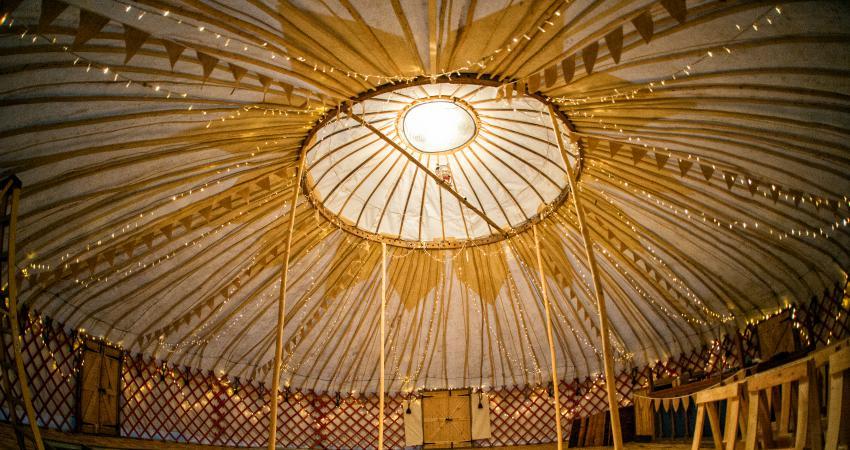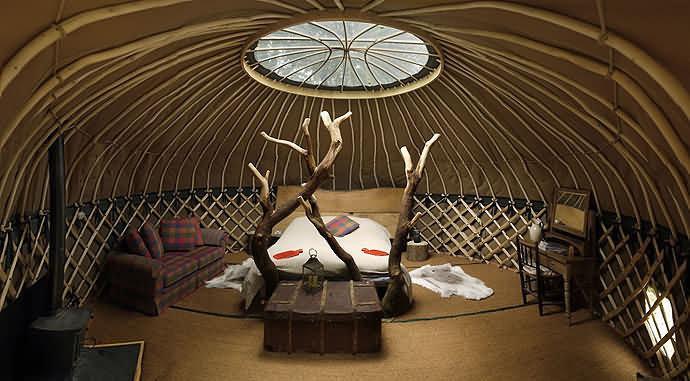The first image is the image on the left, the second image is the image on the right. Given the left and right images, does the statement "There is one bed in the image on the right." hold true? Answer yes or no. Yes. 